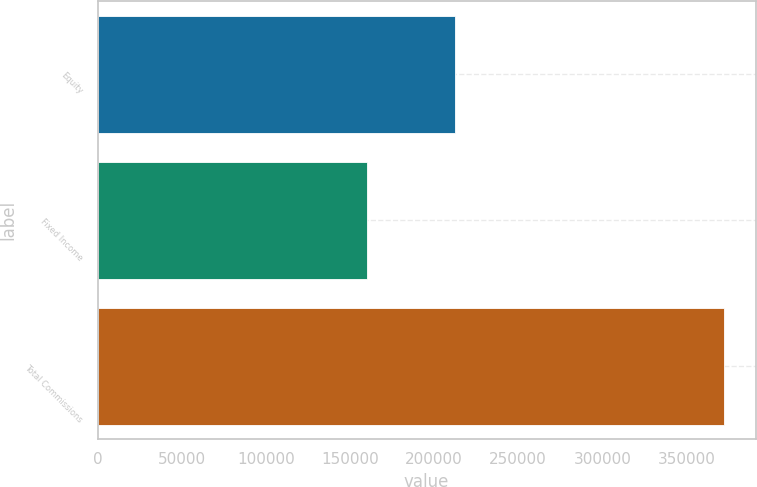<chart> <loc_0><loc_0><loc_500><loc_500><bar_chart><fcel>Equity<fcel>Fixed Income<fcel>Total Commissions<nl><fcel>212322<fcel>160211<fcel>372533<nl></chart> 